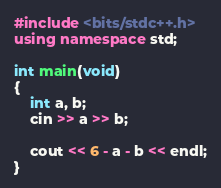<code> <loc_0><loc_0><loc_500><loc_500><_C++_>#include <bits/stdc++.h>
using namespace std;

int main(void)
{
    int a, b;
    cin >> a >> b;
    
    cout << 6 - a - b << endl;
}
</code> 